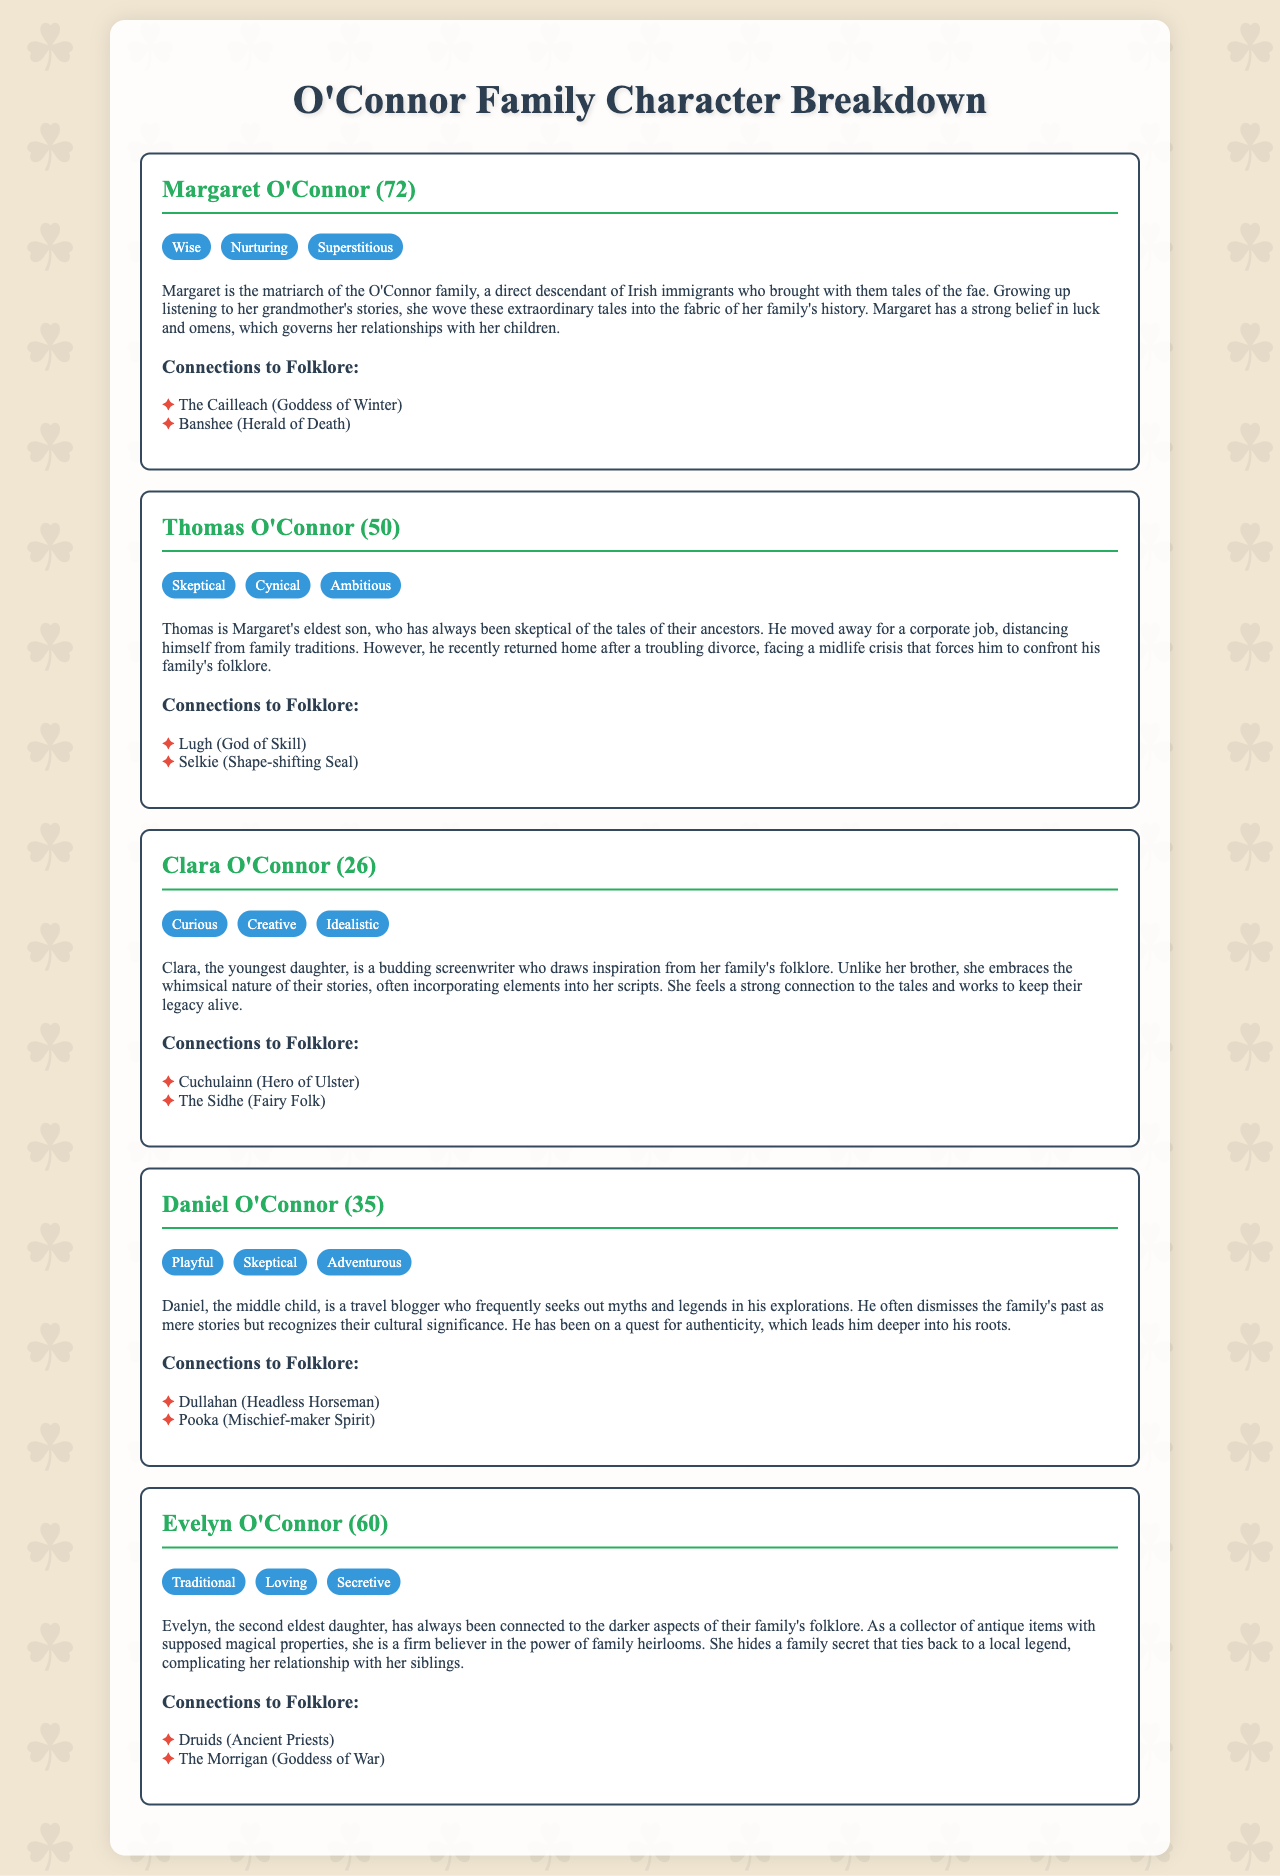What is the name of the matriarch? The matriarch of the O'Connor family is named Margaret O'Connor.
Answer: Margaret O'Connor How old is Thomas O'Connor? Thomas O'Connor is specified to be 50 years old in the document.
Answer: 50 What trait is associated with Clara O'Connor? Clara O'Connor is noted for being curious, among other traits.
Answer: Curious Which folklore character is connected to Daniel O'Connor? Daniel O'Connor has connections to the Dullahan, among others.
Answer: Dullahan What does Evelyn O'Connor collect? Evelyn O'Connor collects antique items with supposed magical properties.
Answer: Antique items Which family member is skeptical about their folklore? Thomas O'Connor is portrayed as skeptical about the tales of their ancestors.
Answer: Thomas O'Connor What is the relationship between Clara and Thomas? Clara is Thomas's sister in the O'Connor family structure.
Answer: Sister How is Margaret's belief in omens described? Margaret's belief in luck and omens governs her relationships with her children.
Answer: Governs relationships Which ancient priesthood is mentioned in connection to Evelyn? The document mentions Druids in connection with Evelyn O'Connor.
Answer: Druids 